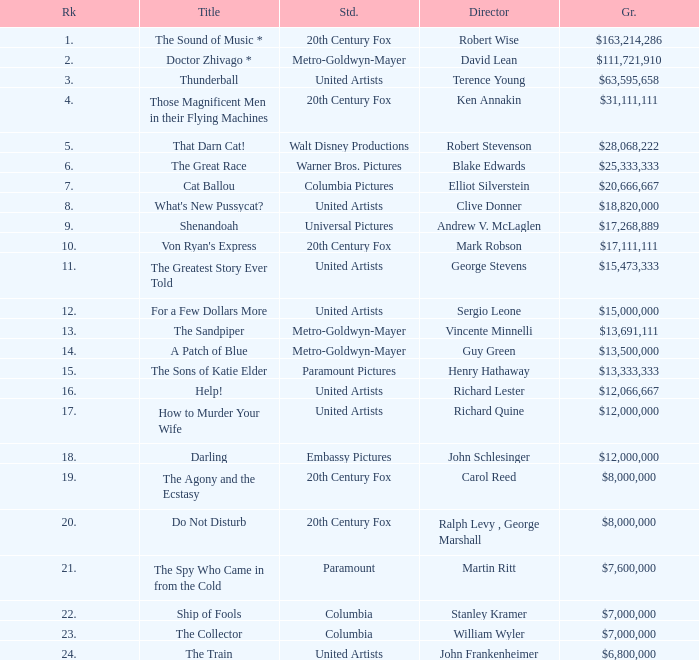What is Title, when Studio is "Embassy Pictures"? Darling. 